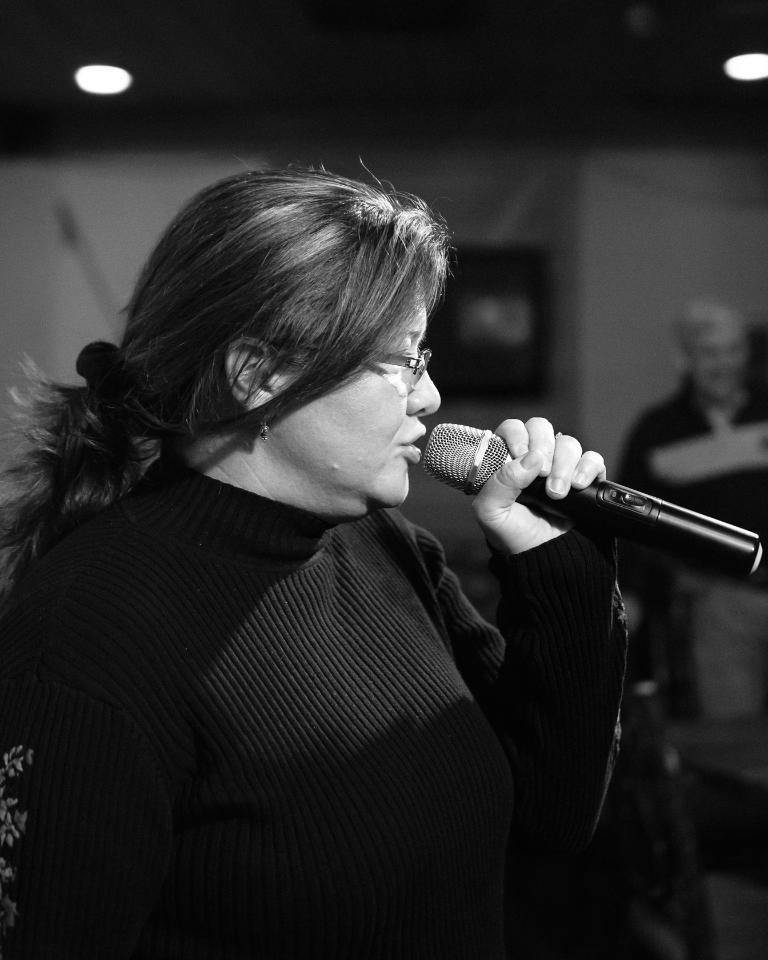Please provide a concise description of this image. A woman is singing in a microphone by holding it in her hand. She is wearing a spectacles, dress the left side of an image there is a light. There is a man at right. 